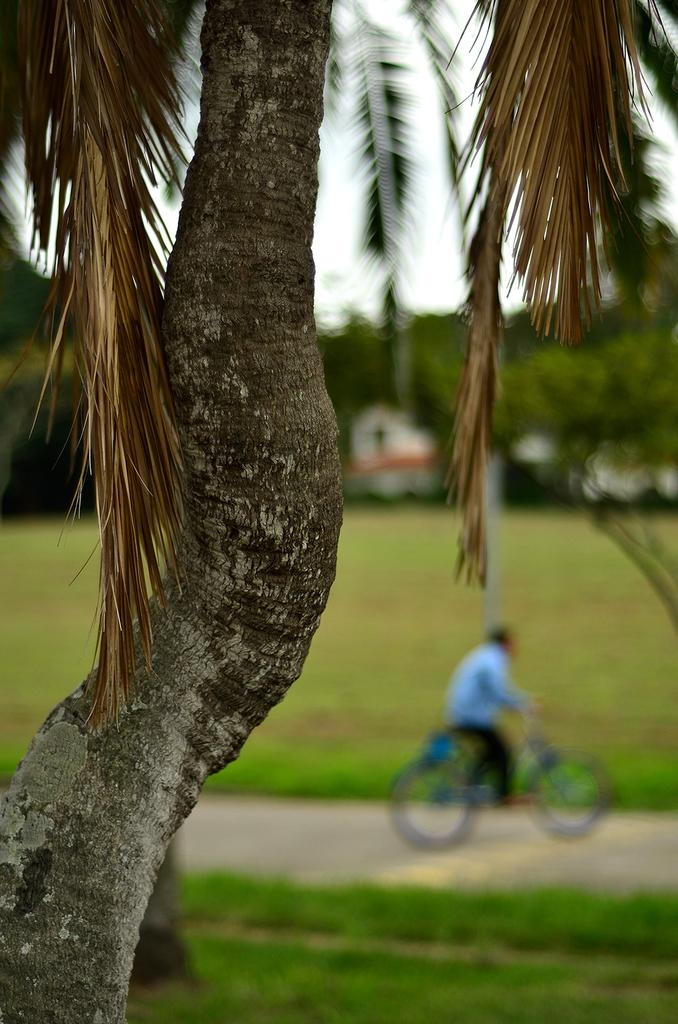What is located in the foreground of the image? There is a tree in the foreground of the image. What activity is taking place in the background of the image? There is a person riding a bicycle in the background of the image. How does the beggar in the image express their love for the tree? There is no beggar present in the image, and the tree is not associated with any expression of love. 